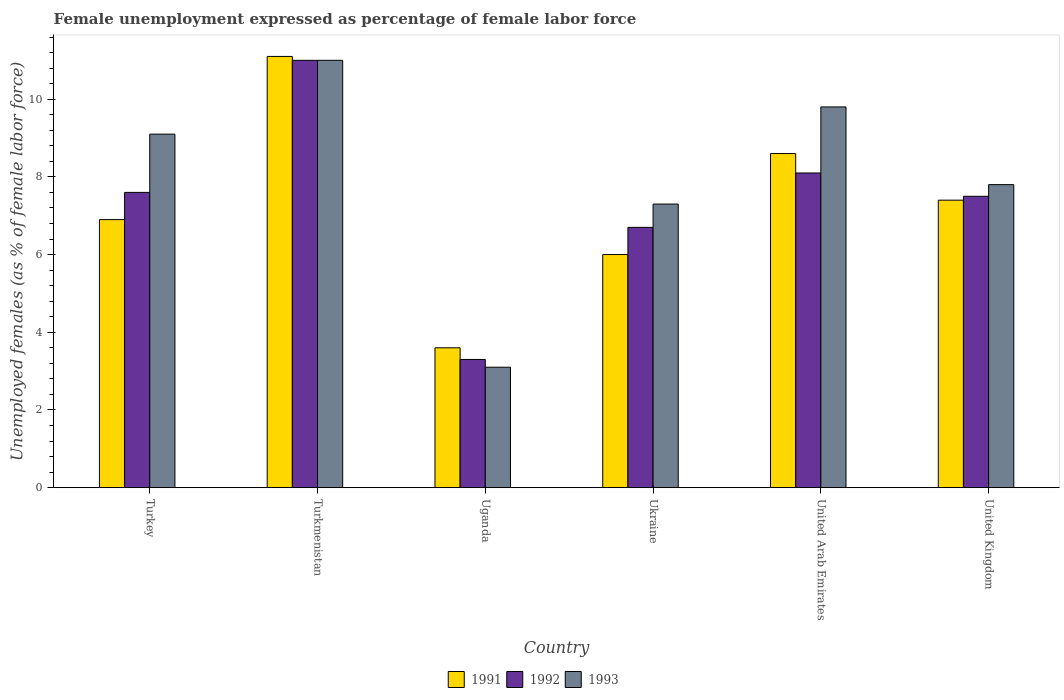How many different coloured bars are there?
Keep it short and to the point. 3. How many groups of bars are there?
Give a very brief answer. 6. Are the number of bars per tick equal to the number of legend labels?
Your response must be concise. Yes. What is the label of the 6th group of bars from the left?
Make the answer very short. United Kingdom. What is the unemployment in females in in 1991 in Turkmenistan?
Your response must be concise. 11.1. Across all countries, what is the maximum unemployment in females in in 1992?
Provide a succinct answer. 11. Across all countries, what is the minimum unemployment in females in in 1993?
Make the answer very short. 3.1. In which country was the unemployment in females in in 1992 maximum?
Keep it short and to the point. Turkmenistan. In which country was the unemployment in females in in 1992 minimum?
Your answer should be very brief. Uganda. What is the total unemployment in females in in 1992 in the graph?
Your response must be concise. 44.2. What is the difference between the unemployment in females in in 1993 in Turkey and that in Turkmenistan?
Provide a succinct answer. -1.9. What is the difference between the unemployment in females in in 1992 in Turkmenistan and the unemployment in females in in 1991 in Turkey?
Ensure brevity in your answer.  4.1. What is the average unemployment in females in in 1991 per country?
Offer a very short reply. 7.27. What is the difference between the unemployment in females in of/in 1993 and unemployment in females in of/in 1992 in Turkey?
Your response must be concise. 1.5. What is the ratio of the unemployment in females in in 1993 in United Arab Emirates to that in United Kingdom?
Offer a terse response. 1.26. Is the difference between the unemployment in females in in 1993 in Turkmenistan and United Kingdom greater than the difference between the unemployment in females in in 1992 in Turkmenistan and United Kingdom?
Provide a short and direct response. No. What is the difference between the highest and the second highest unemployment in females in in 1991?
Your answer should be very brief. -2.5. What is the difference between the highest and the lowest unemployment in females in in 1993?
Your answer should be very brief. 7.9. Is the sum of the unemployment in females in in 1992 in Turkey and Ukraine greater than the maximum unemployment in females in in 1991 across all countries?
Your response must be concise. Yes. What does the 1st bar from the right in Turkmenistan represents?
Offer a terse response. 1993. How many countries are there in the graph?
Offer a terse response. 6. Does the graph contain any zero values?
Make the answer very short. No. Does the graph contain grids?
Offer a very short reply. No. Where does the legend appear in the graph?
Provide a short and direct response. Bottom center. What is the title of the graph?
Offer a very short reply. Female unemployment expressed as percentage of female labor force. Does "1980" appear as one of the legend labels in the graph?
Provide a succinct answer. No. What is the label or title of the Y-axis?
Your answer should be compact. Unemployed females (as % of female labor force). What is the Unemployed females (as % of female labor force) in 1991 in Turkey?
Provide a succinct answer. 6.9. What is the Unemployed females (as % of female labor force) of 1992 in Turkey?
Offer a terse response. 7.6. What is the Unemployed females (as % of female labor force) of 1993 in Turkey?
Your answer should be compact. 9.1. What is the Unemployed females (as % of female labor force) of 1991 in Turkmenistan?
Keep it short and to the point. 11.1. What is the Unemployed females (as % of female labor force) in 1991 in Uganda?
Offer a terse response. 3.6. What is the Unemployed females (as % of female labor force) of 1992 in Uganda?
Your answer should be very brief. 3.3. What is the Unemployed females (as % of female labor force) of 1993 in Uganda?
Your response must be concise. 3.1. What is the Unemployed females (as % of female labor force) of 1992 in Ukraine?
Your answer should be very brief. 6.7. What is the Unemployed females (as % of female labor force) of 1993 in Ukraine?
Your answer should be compact. 7.3. What is the Unemployed females (as % of female labor force) of 1991 in United Arab Emirates?
Your answer should be compact. 8.6. What is the Unemployed females (as % of female labor force) in 1992 in United Arab Emirates?
Your response must be concise. 8.1. What is the Unemployed females (as % of female labor force) in 1993 in United Arab Emirates?
Offer a very short reply. 9.8. What is the Unemployed females (as % of female labor force) of 1991 in United Kingdom?
Keep it short and to the point. 7.4. What is the Unemployed females (as % of female labor force) of 1993 in United Kingdom?
Offer a terse response. 7.8. Across all countries, what is the maximum Unemployed females (as % of female labor force) in 1991?
Provide a short and direct response. 11.1. Across all countries, what is the maximum Unemployed females (as % of female labor force) in 1993?
Ensure brevity in your answer.  11. Across all countries, what is the minimum Unemployed females (as % of female labor force) in 1991?
Ensure brevity in your answer.  3.6. Across all countries, what is the minimum Unemployed females (as % of female labor force) of 1992?
Make the answer very short. 3.3. Across all countries, what is the minimum Unemployed females (as % of female labor force) in 1993?
Your answer should be compact. 3.1. What is the total Unemployed females (as % of female labor force) in 1991 in the graph?
Your answer should be compact. 43.6. What is the total Unemployed females (as % of female labor force) of 1992 in the graph?
Ensure brevity in your answer.  44.2. What is the total Unemployed females (as % of female labor force) of 1993 in the graph?
Provide a short and direct response. 48.1. What is the difference between the Unemployed females (as % of female labor force) of 1991 in Turkey and that in Turkmenistan?
Give a very brief answer. -4.2. What is the difference between the Unemployed females (as % of female labor force) of 1993 in Turkey and that in Turkmenistan?
Keep it short and to the point. -1.9. What is the difference between the Unemployed females (as % of female labor force) in 1993 in Turkey and that in United Arab Emirates?
Provide a succinct answer. -0.7. What is the difference between the Unemployed females (as % of female labor force) in 1993 in Turkey and that in United Kingdom?
Offer a terse response. 1.3. What is the difference between the Unemployed females (as % of female labor force) in 1991 in Turkmenistan and that in Uganda?
Offer a terse response. 7.5. What is the difference between the Unemployed females (as % of female labor force) of 1992 in Turkmenistan and that in Uganda?
Your answer should be compact. 7.7. What is the difference between the Unemployed females (as % of female labor force) in 1993 in Turkmenistan and that in Ukraine?
Provide a succinct answer. 3.7. What is the difference between the Unemployed females (as % of female labor force) of 1992 in Turkmenistan and that in United Kingdom?
Ensure brevity in your answer.  3.5. What is the difference between the Unemployed females (as % of female labor force) in 1993 in Turkmenistan and that in United Kingdom?
Offer a terse response. 3.2. What is the difference between the Unemployed females (as % of female labor force) in 1991 in Uganda and that in United Arab Emirates?
Provide a succinct answer. -5. What is the difference between the Unemployed females (as % of female labor force) in 1992 in Uganda and that in United Arab Emirates?
Provide a short and direct response. -4.8. What is the difference between the Unemployed females (as % of female labor force) in 1993 in Uganda and that in United Arab Emirates?
Offer a very short reply. -6.7. What is the difference between the Unemployed females (as % of female labor force) in 1992 in Uganda and that in United Kingdom?
Make the answer very short. -4.2. What is the difference between the Unemployed females (as % of female labor force) of 1993 in Uganda and that in United Kingdom?
Your response must be concise. -4.7. What is the difference between the Unemployed females (as % of female labor force) in 1991 in Ukraine and that in United Kingdom?
Your response must be concise. -1.4. What is the difference between the Unemployed females (as % of female labor force) of 1992 in Ukraine and that in United Kingdom?
Provide a short and direct response. -0.8. What is the difference between the Unemployed females (as % of female labor force) of 1991 in United Arab Emirates and that in United Kingdom?
Your answer should be compact. 1.2. What is the difference between the Unemployed females (as % of female labor force) in 1991 in Turkey and the Unemployed females (as % of female labor force) in 1992 in Turkmenistan?
Offer a very short reply. -4.1. What is the difference between the Unemployed females (as % of female labor force) in 1991 in Turkey and the Unemployed females (as % of female labor force) in 1992 in Uganda?
Ensure brevity in your answer.  3.6. What is the difference between the Unemployed females (as % of female labor force) in 1991 in Turkey and the Unemployed females (as % of female labor force) in 1993 in Uganda?
Provide a succinct answer. 3.8. What is the difference between the Unemployed females (as % of female labor force) of 1991 in Turkey and the Unemployed females (as % of female labor force) of 1993 in Ukraine?
Provide a succinct answer. -0.4. What is the difference between the Unemployed females (as % of female labor force) of 1992 in Turkmenistan and the Unemployed females (as % of female labor force) of 1993 in Uganda?
Offer a terse response. 7.9. What is the difference between the Unemployed females (as % of female labor force) of 1992 in Turkmenistan and the Unemployed females (as % of female labor force) of 1993 in Ukraine?
Ensure brevity in your answer.  3.7. What is the difference between the Unemployed females (as % of female labor force) of 1991 in Turkmenistan and the Unemployed females (as % of female labor force) of 1992 in United Arab Emirates?
Make the answer very short. 3. What is the difference between the Unemployed females (as % of female labor force) of 1992 in Turkmenistan and the Unemployed females (as % of female labor force) of 1993 in United Arab Emirates?
Your response must be concise. 1.2. What is the difference between the Unemployed females (as % of female labor force) in 1992 in Turkmenistan and the Unemployed females (as % of female labor force) in 1993 in United Kingdom?
Provide a short and direct response. 3.2. What is the difference between the Unemployed females (as % of female labor force) in 1991 in Uganda and the Unemployed females (as % of female labor force) in 1993 in Ukraine?
Make the answer very short. -3.7. What is the difference between the Unemployed females (as % of female labor force) of 1992 in Uganda and the Unemployed females (as % of female labor force) of 1993 in Ukraine?
Your answer should be very brief. -4. What is the difference between the Unemployed females (as % of female labor force) in 1991 in Uganda and the Unemployed females (as % of female labor force) in 1992 in United Arab Emirates?
Offer a very short reply. -4.5. What is the difference between the Unemployed females (as % of female labor force) of 1991 in Uganda and the Unemployed females (as % of female labor force) of 1993 in United Kingdom?
Ensure brevity in your answer.  -4.2. What is the difference between the Unemployed females (as % of female labor force) in 1991 in Ukraine and the Unemployed females (as % of female labor force) in 1992 in United Arab Emirates?
Give a very brief answer. -2.1. What is the difference between the Unemployed females (as % of female labor force) in 1991 in Ukraine and the Unemployed females (as % of female labor force) in 1993 in United Arab Emirates?
Offer a very short reply. -3.8. What is the difference between the Unemployed females (as % of female labor force) in 1992 in Ukraine and the Unemployed females (as % of female labor force) in 1993 in United Kingdom?
Offer a very short reply. -1.1. What is the difference between the Unemployed females (as % of female labor force) in 1991 in United Arab Emirates and the Unemployed females (as % of female labor force) in 1992 in United Kingdom?
Ensure brevity in your answer.  1.1. What is the average Unemployed females (as % of female labor force) in 1991 per country?
Ensure brevity in your answer.  7.27. What is the average Unemployed females (as % of female labor force) in 1992 per country?
Your answer should be very brief. 7.37. What is the average Unemployed females (as % of female labor force) of 1993 per country?
Offer a very short reply. 8.02. What is the difference between the Unemployed females (as % of female labor force) of 1991 and Unemployed females (as % of female labor force) of 1993 in Turkey?
Your answer should be compact. -2.2. What is the difference between the Unemployed females (as % of female labor force) in 1992 and Unemployed females (as % of female labor force) in 1993 in Turkey?
Your response must be concise. -1.5. What is the difference between the Unemployed females (as % of female labor force) of 1991 and Unemployed females (as % of female labor force) of 1993 in Turkmenistan?
Provide a short and direct response. 0.1. What is the difference between the Unemployed females (as % of female labor force) in 1991 and Unemployed females (as % of female labor force) in 1993 in Uganda?
Ensure brevity in your answer.  0.5. What is the difference between the Unemployed females (as % of female labor force) of 1992 and Unemployed females (as % of female labor force) of 1993 in Uganda?
Keep it short and to the point. 0.2. What is the difference between the Unemployed females (as % of female labor force) in 1991 and Unemployed females (as % of female labor force) in 1993 in Ukraine?
Provide a succinct answer. -1.3. What is the difference between the Unemployed females (as % of female labor force) of 1992 and Unemployed females (as % of female labor force) of 1993 in United Arab Emirates?
Make the answer very short. -1.7. What is the difference between the Unemployed females (as % of female labor force) of 1991 and Unemployed females (as % of female labor force) of 1992 in United Kingdom?
Your answer should be compact. -0.1. What is the difference between the Unemployed females (as % of female labor force) of 1992 and Unemployed females (as % of female labor force) of 1993 in United Kingdom?
Your response must be concise. -0.3. What is the ratio of the Unemployed females (as % of female labor force) in 1991 in Turkey to that in Turkmenistan?
Offer a very short reply. 0.62. What is the ratio of the Unemployed females (as % of female labor force) in 1992 in Turkey to that in Turkmenistan?
Make the answer very short. 0.69. What is the ratio of the Unemployed females (as % of female labor force) of 1993 in Turkey to that in Turkmenistan?
Provide a short and direct response. 0.83. What is the ratio of the Unemployed females (as % of female labor force) of 1991 in Turkey to that in Uganda?
Your answer should be very brief. 1.92. What is the ratio of the Unemployed females (as % of female labor force) of 1992 in Turkey to that in Uganda?
Give a very brief answer. 2.3. What is the ratio of the Unemployed females (as % of female labor force) of 1993 in Turkey to that in Uganda?
Give a very brief answer. 2.94. What is the ratio of the Unemployed females (as % of female labor force) in 1991 in Turkey to that in Ukraine?
Offer a terse response. 1.15. What is the ratio of the Unemployed females (as % of female labor force) of 1992 in Turkey to that in Ukraine?
Ensure brevity in your answer.  1.13. What is the ratio of the Unemployed females (as % of female labor force) in 1993 in Turkey to that in Ukraine?
Provide a short and direct response. 1.25. What is the ratio of the Unemployed females (as % of female labor force) in 1991 in Turkey to that in United Arab Emirates?
Keep it short and to the point. 0.8. What is the ratio of the Unemployed females (as % of female labor force) of 1992 in Turkey to that in United Arab Emirates?
Offer a terse response. 0.94. What is the ratio of the Unemployed females (as % of female labor force) in 1991 in Turkey to that in United Kingdom?
Offer a very short reply. 0.93. What is the ratio of the Unemployed females (as % of female labor force) of 1992 in Turkey to that in United Kingdom?
Your response must be concise. 1.01. What is the ratio of the Unemployed females (as % of female labor force) of 1991 in Turkmenistan to that in Uganda?
Make the answer very short. 3.08. What is the ratio of the Unemployed females (as % of female labor force) in 1992 in Turkmenistan to that in Uganda?
Provide a short and direct response. 3.33. What is the ratio of the Unemployed females (as % of female labor force) of 1993 in Turkmenistan to that in Uganda?
Ensure brevity in your answer.  3.55. What is the ratio of the Unemployed females (as % of female labor force) of 1991 in Turkmenistan to that in Ukraine?
Offer a terse response. 1.85. What is the ratio of the Unemployed females (as % of female labor force) in 1992 in Turkmenistan to that in Ukraine?
Your response must be concise. 1.64. What is the ratio of the Unemployed females (as % of female labor force) of 1993 in Turkmenistan to that in Ukraine?
Offer a very short reply. 1.51. What is the ratio of the Unemployed females (as % of female labor force) of 1991 in Turkmenistan to that in United Arab Emirates?
Give a very brief answer. 1.29. What is the ratio of the Unemployed females (as % of female labor force) of 1992 in Turkmenistan to that in United Arab Emirates?
Your answer should be very brief. 1.36. What is the ratio of the Unemployed females (as % of female labor force) in 1993 in Turkmenistan to that in United Arab Emirates?
Keep it short and to the point. 1.12. What is the ratio of the Unemployed females (as % of female labor force) of 1991 in Turkmenistan to that in United Kingdom?
Your answer should be very brief. 1.5. What is the ratio of the Unemployed females (as % of female labor force) in 1992 in Turkmenistan to that in United Kingdom?
Your answer should be very brief. 1.47. What is the ratio of the Unemployed females (as % of female labor force) in 1993 in Turkmenistan to that in United Kingdom?
Offer a very short reply. 1.41. What is the ratio of the Unemployed females (as % of female labor force) of 1992 in Uganda to that in Ukraine?
Provide a succinct answer. 0.49. What is the ratio of the Unemployed females (as % of female labor force) of 1993 in Uganda to that in Ukraine?
Provide a short and direct response. 0.42. What is the ratio of the Unemployed females (as % of female labor force) of 1991 in Uganda to that in United Arab Emirates?
Offer a terse response. 0.42. What is the ratio of the Unemployed females (as % of female labor force) of 1992 in Uganda to that in United Arab Emirates?
Your response must be concise. 0.41. What is the ratio of the Unemployed females (as % of female labor force) of 1993 in Uganda to that in United Arab Emirates?
Your response must be concise. 0.32. What is the ratio of the Unemployed females (as % of female labor force) in 1991 in Uganda to that in United Kingdom?
Provide a short and direct response. 0.49. What is the ratio of the Unemployed females (as % of female labor force) of 1992 in Uganda to that in United Kingdom?
Give a very brief answer. 0.44. What is the ratio of the Unemployed females (as % of female labor force) of 1993 in Uganda to that in United Kingdom?
Provide a succinct answer. 0.4. What is the ratio of the Unemployed females (as % of female labor force) of 1991 in Ukraine to that in United Arab Emirates?
Provide a succinct answer. 0.7. What is the ratio of the Unemployed females (as % of female labor force) of 1992 in Ukraine to that in United Arab Emirates?
Offer a very short reply. 0.83. What is the ratio of the Unemployed females (as % of female labor force) in 1993 in Ukraine to that in United Arab Emirates?
Ensure brevity in your answer.  0.74. What is the ratio of the Unemployed females (as % of female labor force) in 1991 in Ukraine to that in United Kingdom?
Provide a short and direct response. 0.81. What is the ratio of the Unemployed females (as % of female labor force) of 1992 in Ukraine to that in United Kingdom?
Your response must be concise. 0.89. What is the ratio of the Unemployed females (as % of female labor force) in 1993 in Ukraine to that in United Kingdom?
Make the answer very short. 0.94. What is the ratio of the Unemployed females (as % of female labor force) in 1991 in United Arab Emirates to that in United Kingdom?
Offer a very short reply. 1.16. What is the ratio of the Unemployed females (as % of female labor force) in 1993 in United Arab Emirates to that in United Kingdom?
Provide a succinct answer. 1.26. What is the difference between the highest and the lowest Unemployed females (as % of female labor force) in 1991?
Your answer should be very brief. 7.5. 